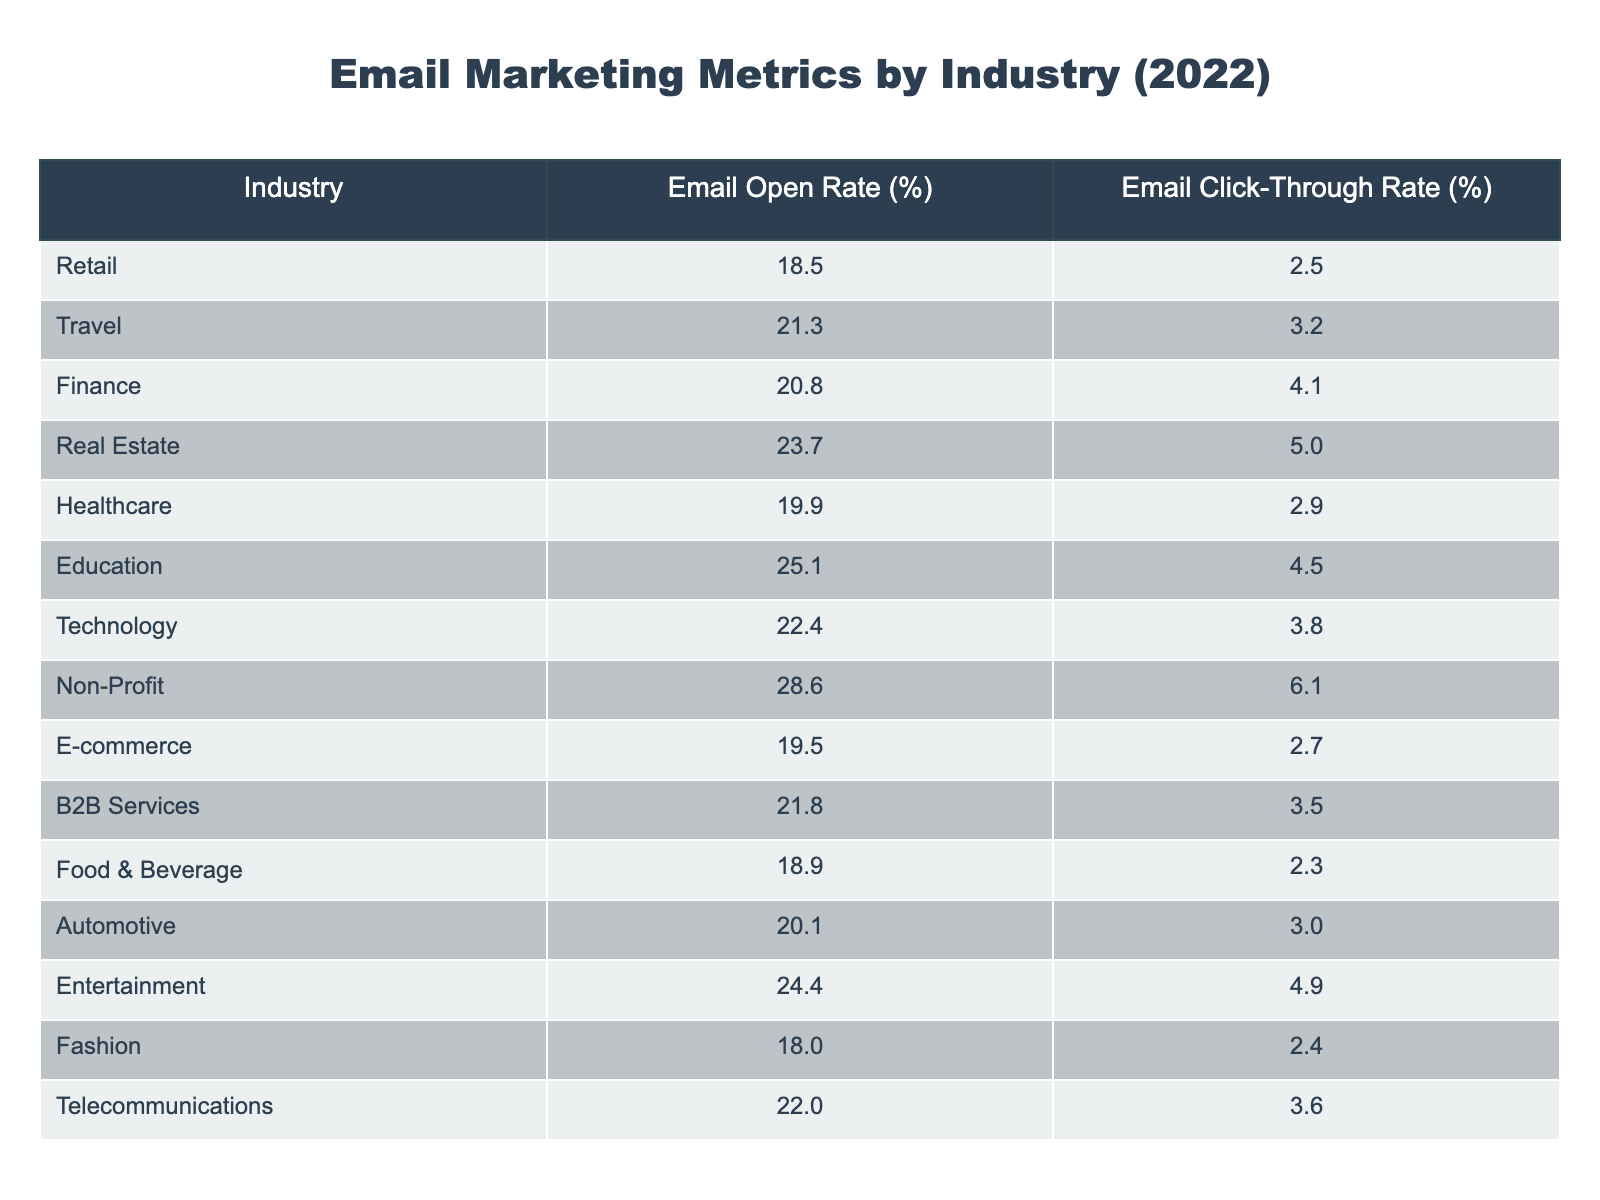What is the email open rate for the Non-Profit industry? The table indicates the email open rate for the Non-Profit industry as 28.6%.
Answer: 28.6% Which industry has the highest email click-through rate? Looking at the table, the Non-Profit industry has the highest email click-through rate at 6.1%.
Answer: 6.1% What is the average email open rate across all industries? To find the average open rate, sum all the open rates (18.5 + 21.3 + 20.8 + 23.7 + 19.9 + 25.1 + 22.4 + 28.6 + 19.5 + 21.8 + 18.9 + 20.1 + 24.4 + 18.0 + 22.0) = 302.6 and divide by 15 industries: 302.6/15 = 20.17%.
Answer: 20.17% Is the email click-through rate for the Technology industry greater than 4%? The Technology industry has a click-through rate of 3.8%, which is less than 4%. Therefore, the answer is no.
Answer: No Which industry has a higher email open rate, Education or Healthcare? The email open rate for Education is 25.1%, while for Healthcare it is 19.9%. Thus, Education has a higher open rate.
Answer: Education What is the difference in click-through rates between the Finance and Automotive industries? The Finance industry has a click-through rate of 4.1%, while Automotive has 3.0%. The difference is: 4.1 - 3.0 = 1.1%.
Answer: 1.1% What percentage of the industries listed have an email open rate above 22%? The industries with open rates above 22% are: Real Estate (23.7%), Education (25.1%), Technology (22.4%), and Non-Profit (28.6%). There are 4 such industries out of 15, so (4/15)*100 = 26.67%.
Answer: 26.67% Does the Entertainment industry have a higher click-through rate than the Fashion industry? The Entertainment industry has a click-through rate of 4.9% compared to Fashion's 2.4%. Since 4.9% is greater than 2.4%, the answer is yes.
Answer: Yes 